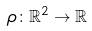<formula> <loc_0><loc_0><loc_500><loc_500>\rho \colon \mathbb { R } ^ { 2 } \to \mathbb { R }</formula> 